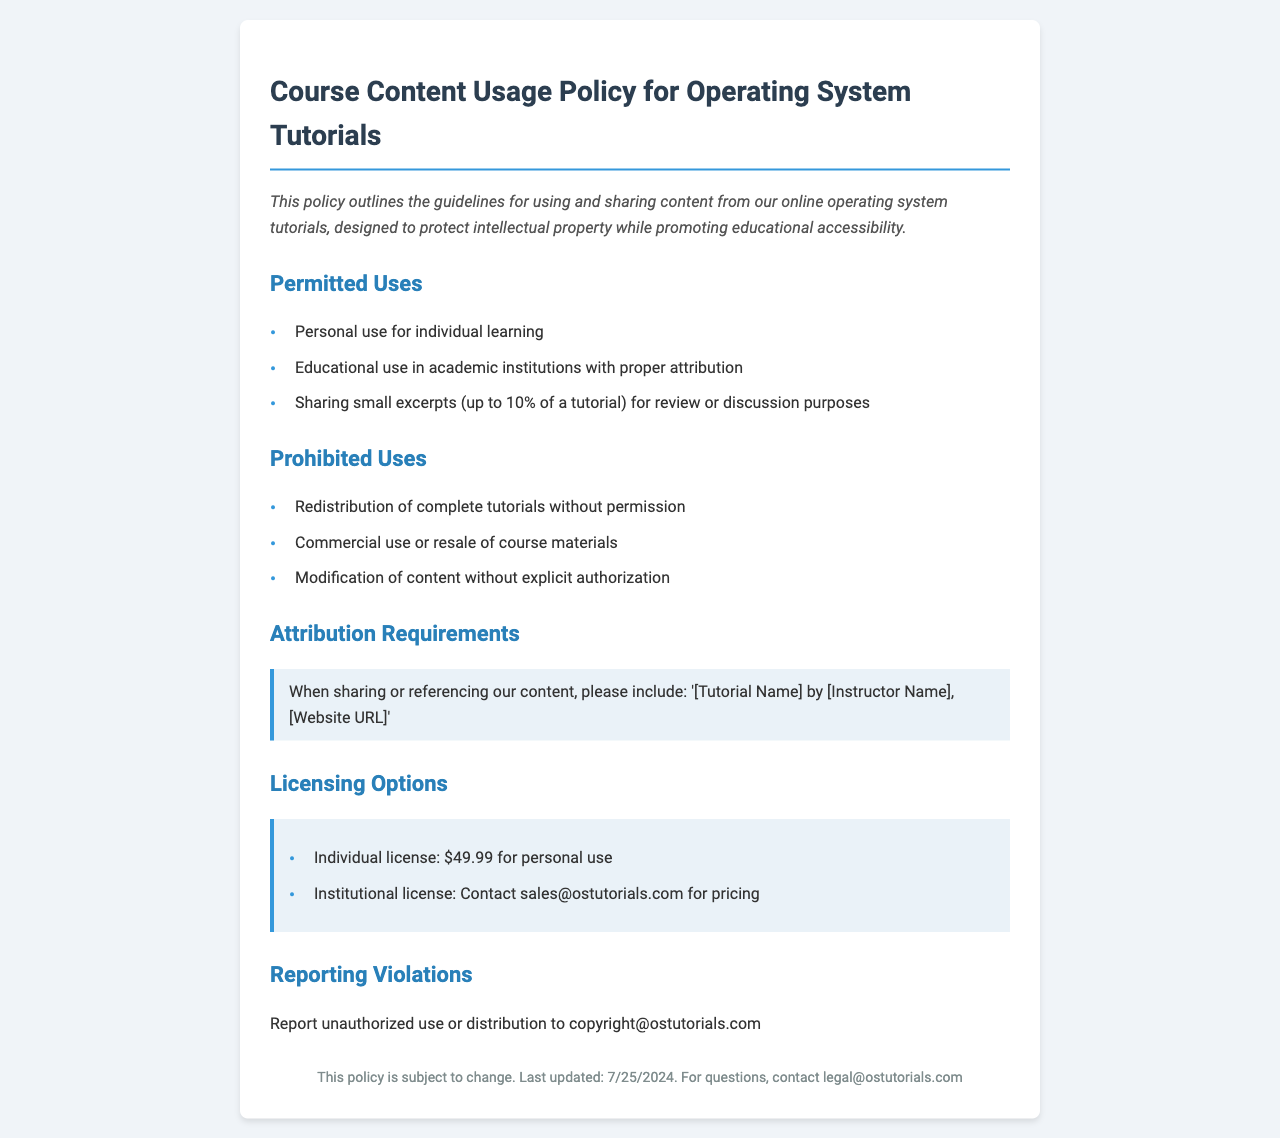What are the permitted uses of the course content? The permitted uses include personal use for individual learning, educational use in academic institutions with proper attribution, and sharing small excerpts (up to 10% of a tutorial) for review or discussion purposes.
Answer: Personal use, educational use, sharing small excerpts What is prohibited regarding the redistribution of tutorials? Redistribution of complete tutorials without permission is prohibited.
Answer: Redistribution of complete tutorials without permission What must be included when sharing or referencing content? Attribution requirements indicate that '[Tutorial Name] by [Instructor Name], [Website URL]' must be included.
Answer: '[Tutorial Name] by [Instructor Name], [Website URL]' What is the price of an individual license? The document states that the individual license costs $49.99 for personal use.
Answer: $49.99 How can unauthorized use be reported? Unauthorized use or distribution should be reported to copyright@ostutorials.com as stated in the document.
Answer: copyright@ostutorials.com What is the last updated date format? The last updated date is presented in the format of the current date when the document is viewed.
Answer: Current date What kind of license should institutions contact for pricing? Institutions are advised to contact sales@ostutorials.com for pricing regarding the institutional license.
Answer: sales@ostutorials.com What are the key elements of the introduction? The introduction outlines the guidelines for using and sharing content, focusing on protecting intellectual property while promoting educational accessibility.
Answer: Protecting intellectual property, promoting educational accessibility 